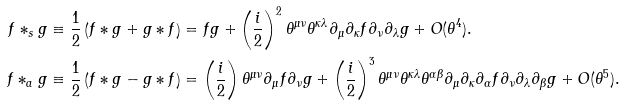Convert formula to latex. <formula><loc_0><loc_0><loc_500><loc_500>f \ast _ { s } g & \equiv \frac { 1 } { 2 } \left ( f \ast g + g \ast f \right ) = f g + \left ( \frac { i } { 2 } \right ) ^ { 2 } \theta ^ { \mu \nu } \theta ^ { \kappa \lambda } \partial _ { \mu } \partial _ { \kappa } f \partial _ { \nu } \partial _ { \lambda } g + O ( \theta ^ { 4 } ) . \\ f \ast _ { a } g & \equiv \frac { 1 } { 2 } \left ( f \ast g - g \ast f \right ) = \left ( \frac { i } { 2 } \right ) \theta ^ { \mu \nu } \partial _ { \mu } f \partial _ { \nu } g + \left ( \frac { i } { 2 } \right ) ^ { 3 } \theta ^ { \mu \nu } \theta ^ { \kappa \lambda } \theta ^ { \alpha \beta } \partial _ { \mu } \partial _ { \kappa } \partial _ { \alpha } f \partial _ { \nu } \partial _ { \lambda } \partial _ { \beta } g + O ( \theta ^ { 5 } ) .</formula> 